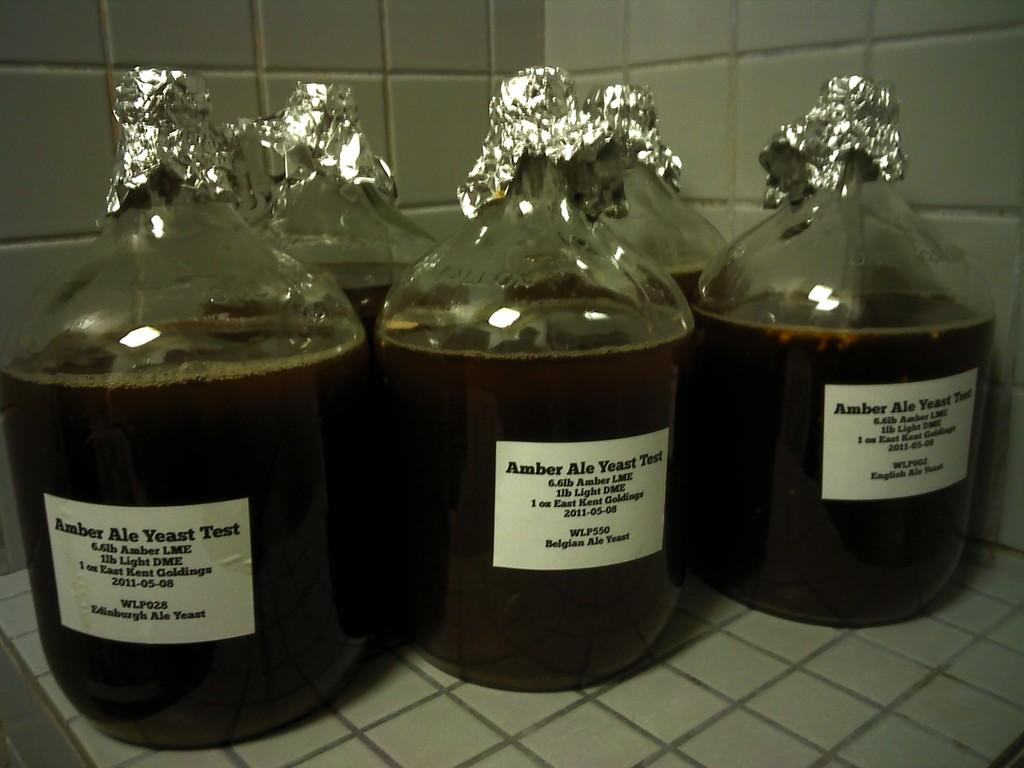<image>
Provide a brief description of the given image. A group of bottles labeled Amber Ale Yeast Test 